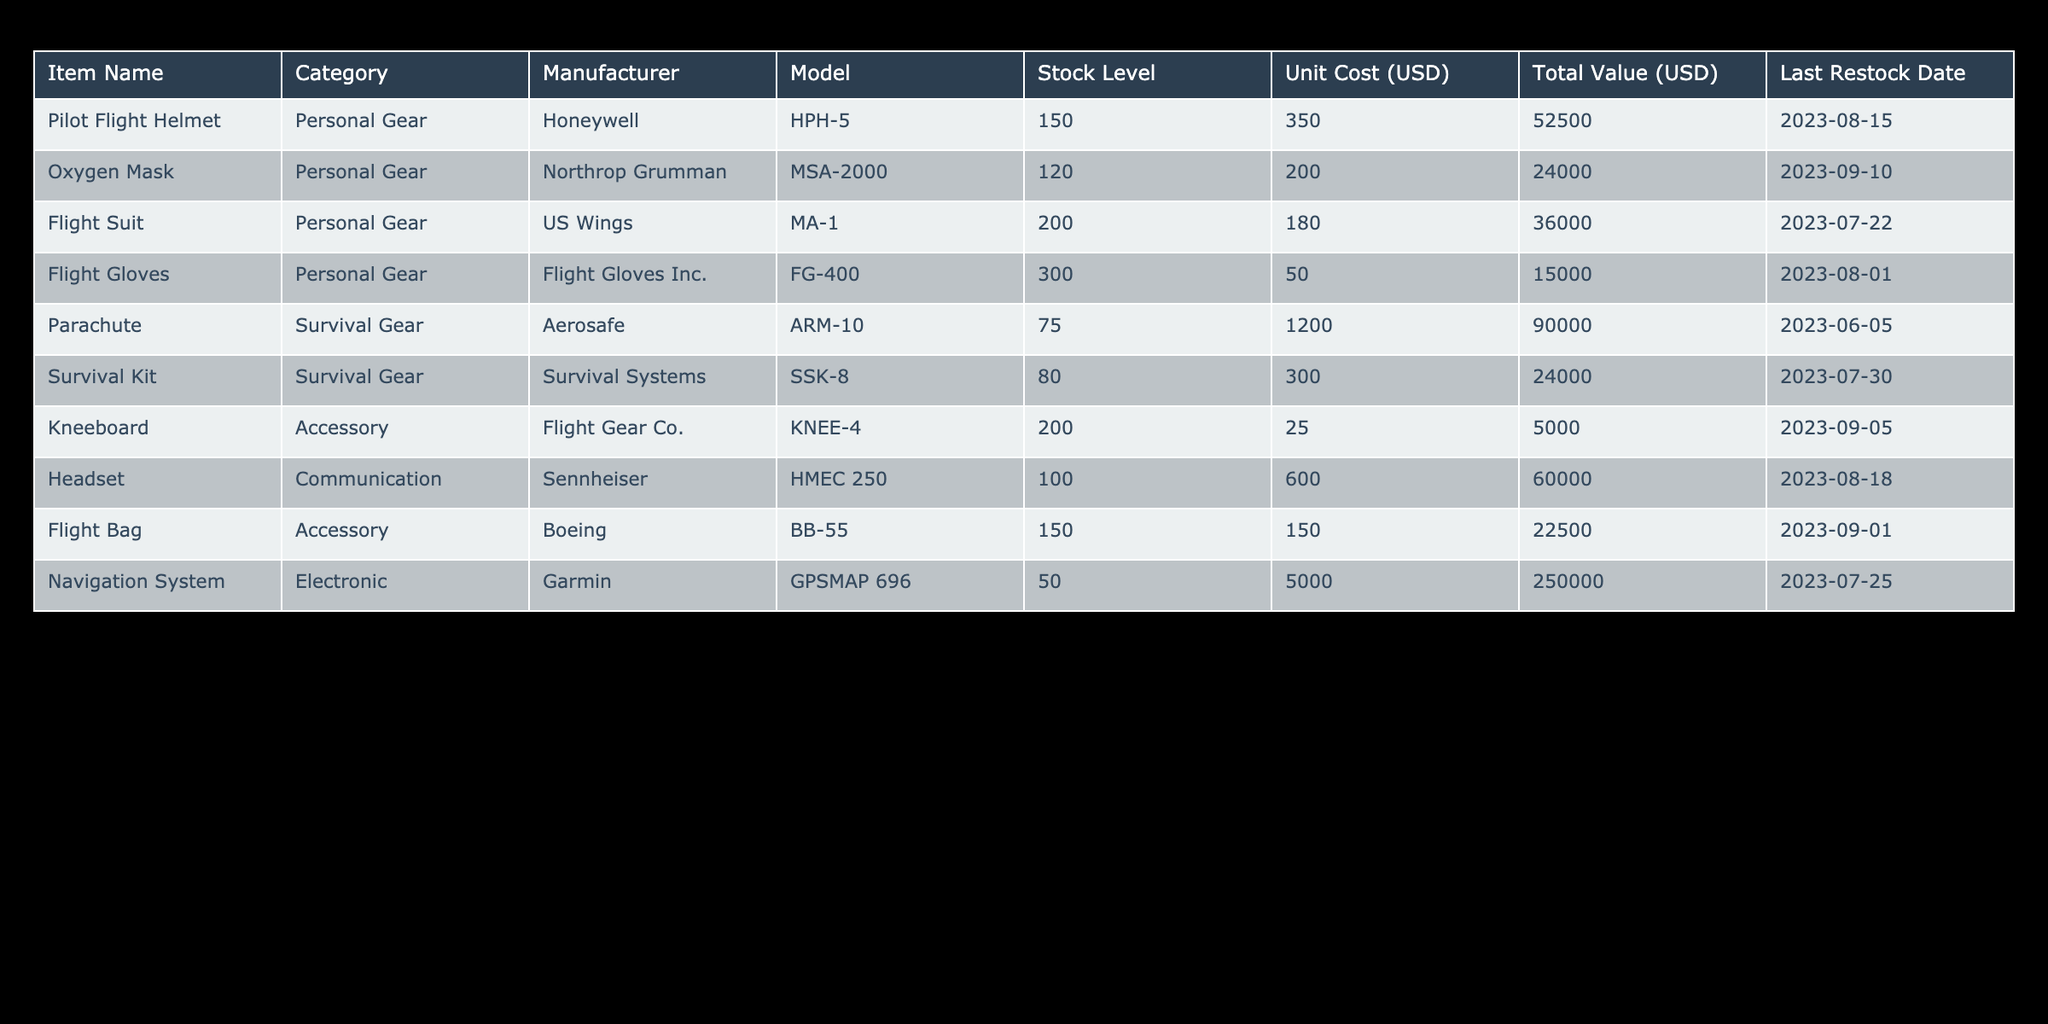What is the stock level of the Parachute? The table provides the stock level for each item. For the Parachute, the stock level is listed directly next to it.
Answer: 75 Which item has the highest total value? By reviewing the Total Value column in the table, we can identify that the Navigation System has the highest total value at 250,000 USD.
Answer: Navigation System What is the total value of the Personal Gear category? To find the total value of the Personal Gear, we sum up the Total Value for each item in that category: Pilot Flight Helmet (52,500) + Oxygen Mask (24,000) + Flight Suit (36,000) + Flight Gloves (15,000) = 127,500.
Answer: 127,500 Is the stock level of Flight Gloves higher than 250? The table shows that the stock level for Flight Gloves is 300. Since 300 is greater than 250, the answer is yes.
Answer: Yes What is the average unit cost of the Survival Gear items? The unit costs of the Survival Gear items are 1,200 for Parachute and 300 for Survival Kit. The average is calculated as (1,200 + 300) / 2 = 750.
Answer: 750 Which manufacturer produces the Oxygen Mask? The information in the table lists the manufacturer associated with each item. The Oxygen Mask is produced by Northrop Grumman.
Answer: Northrop Grumman How much does a Flight Bag cost compared to a Headset? According to the table, the Flight Bag costs 150 USD while the Headset costs 600 USD. The difference is 600 - 150 = 450.
Answer: 450 What is the total stock level for all Electronic category items? To find the total stock for Electronic items, we only have the Navigation System with a stock level of 50. Thus, the total is 50.
Answer: 50 How many items have a last restock date in August 2023? By reviewing the Last Restock Date column, we find items with dates in August 2023: Pilot Flight Helmet, Flight Gloves, and Headset. That makes it three items.
Answer: 3 